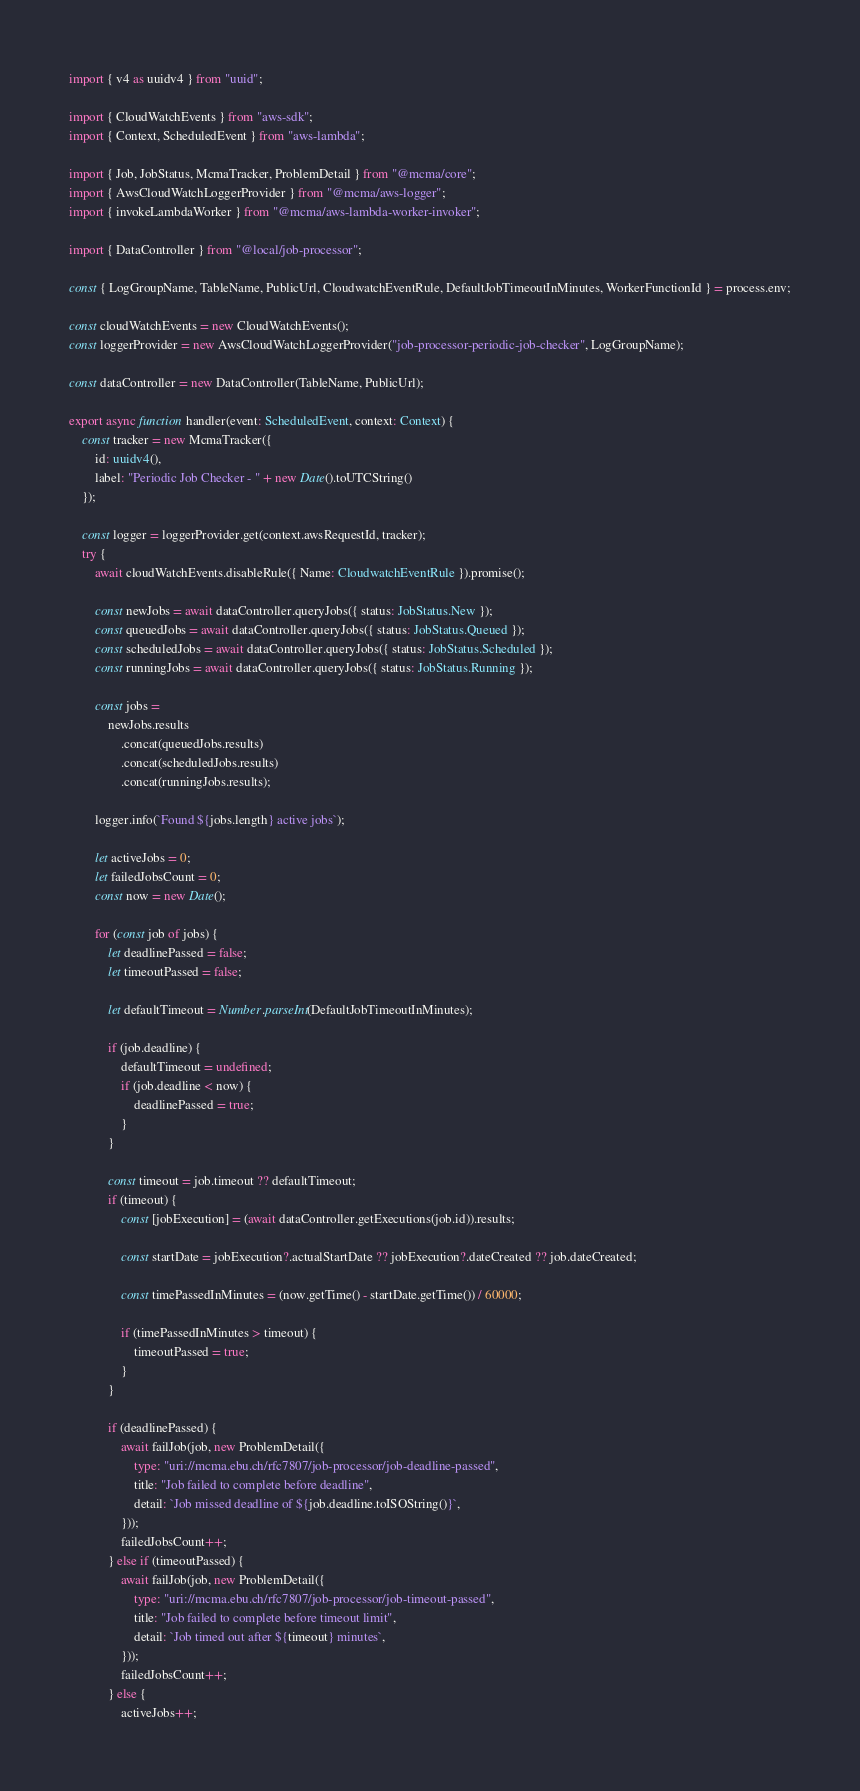<code> <loc_0><loc_0><loc_500><loc_500><_TypeScript_>import { v4 as uuidv4 } from "uuid";

import { CloudWatchEvents } from "aws-sdk";
import { Context, ScheduledEvent } from "aws-lambda";

import { Job, JobStatus, McmaTracker, ProblemDetail } from "@mcma/core";
import { AwsCloudWatchLoggerProvider } from "@mcma/aws-logger";
import { invokeLambdaWorker } from "@mcma/aws-lambda-worker-invoker";

import { DataController } from "@local/job-processor";

const { LogGroupName, TableName, PublicUrl, CloudwatchEventRule, DefaultJobTimeoutInMinutes, WorkerFunctionId } = process.env;

const cloudWatchEvents = new CloudWatchEvents();
const loggerProvider = new AwsCloudWatchLoggerProvider("job-processor-periodic-job-checker", LogGroupName);

const dataController = new DataController(TableName, PublicUrl);

export async function handler(event: ScheduledEvent, context: Context) {
    const tracker = new McmaTracker({
        id: uuidv4(),
        label: "Periodic Job Checker - " + new Date().toUTCString()
    });

    const logger = loggerProvider.get(context.awsRequestId, tracker);
    try {
        await cloudWatchEvents.disableRule({ Name: CloudwatchEventRule }).promise();

        const newJobs = await dataController.queryJobs({ status: JobStatus.New });
        const queuedJobs = await dataController.queryJobs({ status: JobStatus.Queued });
        const scheduledJobs = await dataController.queryJobs({ status: JobStatus.Scheduled });
        const runningJobs = await dataController.queryJobs({ status: JobStatus.Running });

        const jobs =
            newJobs.results
                .concat(queuedJobs.results)
                .concat(scheduledJobs.results)
                .concat(runningJobs.results);

        logger.info(`Found ${jobs.length} active jobs`);

        let activeJobs = 0;
        let failedJobsCount = 0;
        const now = new Date();

        for (const job of jobs) {
            let deadlinePassed = false;
            let timeoutPassed = false;

            let defaultTimeout = Number.parseInt(DefaultJobTimeoutInMinutes);

            if (job.deadline) {
                defaultTimeout = undefined;
                if (job.deadline < now) {
                    deadlinePassed = true;
                }
            }

            const timeout = job.timeout ?? defaultTimeout;
            if (timeout) {
                const [jobExecution] = (await dataController.getExecutions(job.id)).results;

                const startDate = jobExecution?.actualStartDate ?? jobExecution?.dateCreated ?? job.dateCreated;

                const timePassedInMinutes = (now.getTime() - startDate.getTime()) / 60000;

                if (timePassedInMinutes > timeout) {
                    timeoutPassed = true;
                }
            }

            if (deadlinePassed) {
                await failJob(job, new ProblemDetail({
                    type: "uri://mcma.ebu.ch/rfc7807/job-processor/job-deadline-passed",
                    title: "Job failed to complete before deadline",
                    detail: `Job missed deadline of ${job.deadline.toISOString()}`,
                }));
                failedJobsCount++;
            } else if (timeoutPassed) {
                await failJob(job, new ProblemDetail({
                    type: "uri://mcma.ebu.ch/rfc7807/job-processor/job-timeout-passed",
                    title: "Job failed to complete before timeout limit",
                    detail: `Job timed out after ${timeout} minutes`,
                }));
                failedJobsCount++;
            } else {
                activeJobs++;</code> 